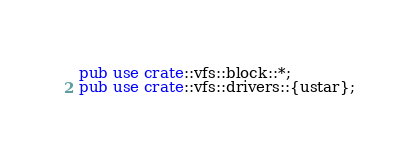Convert code to text. <code><loc_0><loc_0><loc_500><loc_500><_Rust_>pub use crate::vfs::block::*;
pub use crate::vfs::drivers::{ustar};

</code> 